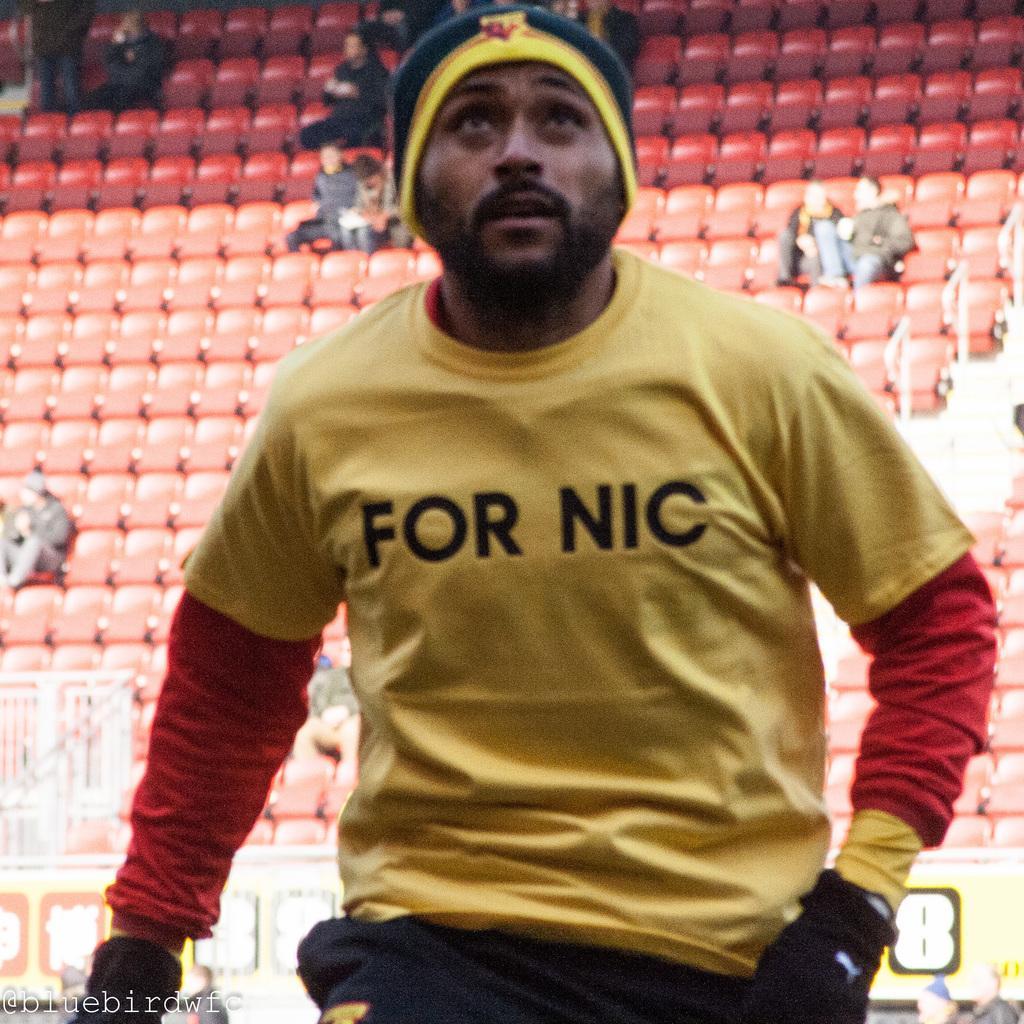Could you give a brief overview of what you see in this image? Front we can see a person. Background it is blur. We can see chairs and people. Few people are sitting on chairs. Bottom of the image there is a watermark. 